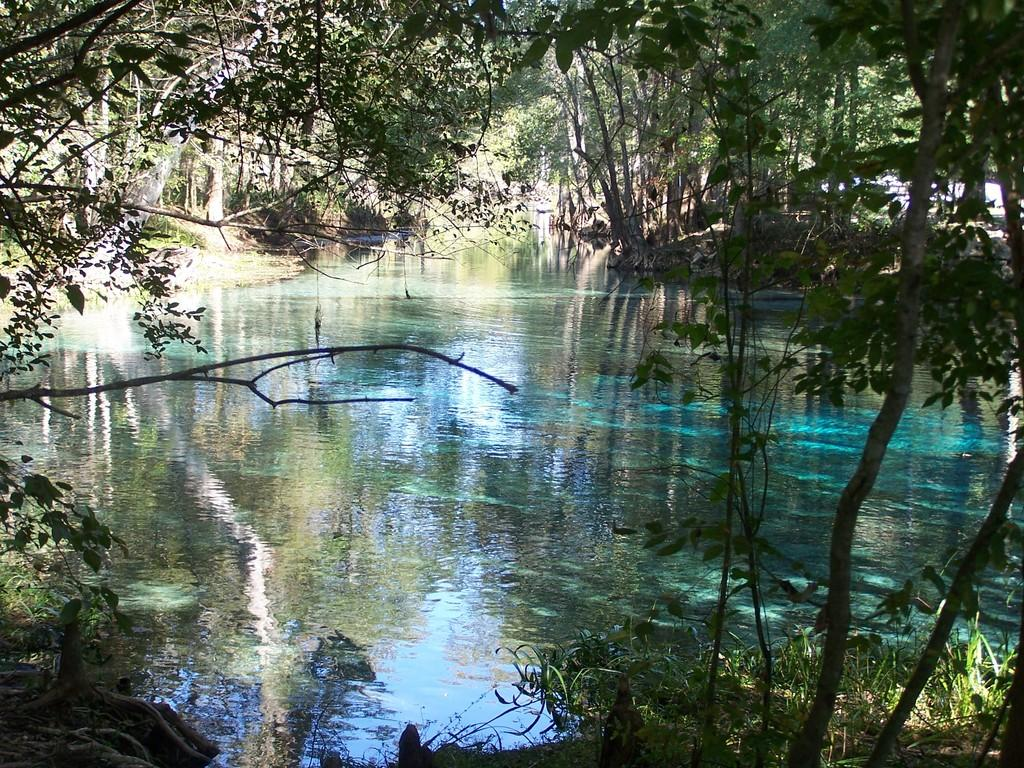What type of natural environment is depicted in the image? The image features water, grass, and trees, which are elements commonly found in natural environments. Can you describe the water in the image? The water is visible in the image, but its specific characteristics are not mentioned in the provided facts. What type of vegetation is present in the image? There are trees in the image, as well as grass. How many babies are wearing gloves and playing with a force in the image? There are no babies, gloves, or forces present in the image; it features water, grass, and trees. 